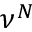Convert formula to latex. <formula><loc_0><loc_0><loc_500><loc_500>\nu ^ { N }</formula> 